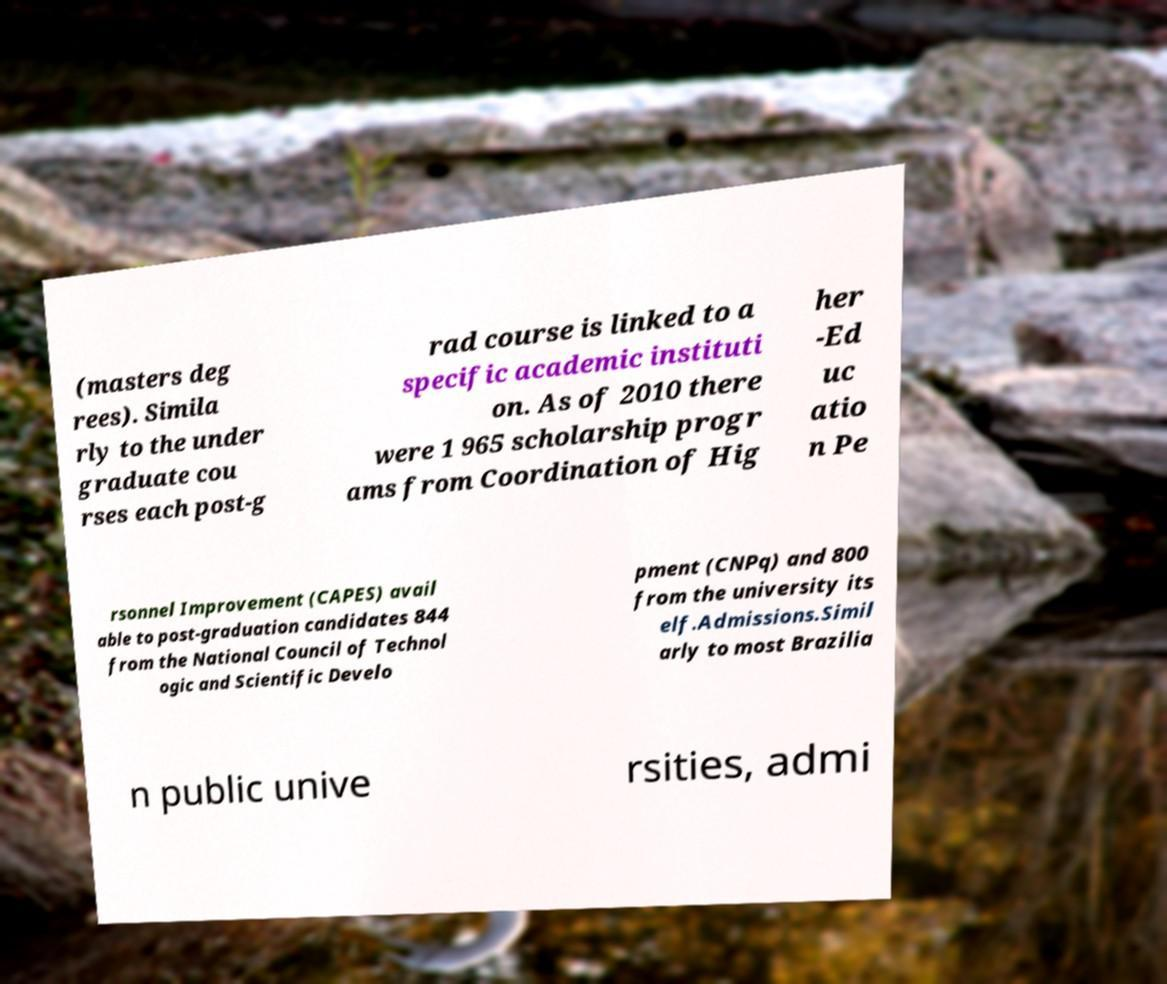What messages or text are displayed in this image? I need them in a readable, typed format. (masters deg rees). Simila rly to the under graduate cou rses each post-g rad course is linked to a specific academic instituti on. As of 2010 there were 1 965 scholarship progr ams from Coordination of Hig her -Ed uc atio n Pe rsonnel Improvement (CAPES) avail able to post-graduation candidates 844 from the National Council of Technol ogic and Scientific Develo pment (CNPq) and 800 from the university its elf.Admissions.Simil arly to most Brazilia n public unive rsities, admi 